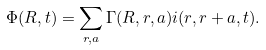<formula> <loc_0><loc_0><loc_500><loc_500>\Phi ( { R } , t ) = \sum _ { { r } , { a } } \Gamma ( { R } , { r } , { a } ) i ( { r } , { r + a } , t ) .</formula> 